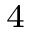Convert formula to latex. <formula><loc_0><loc_0><loc_500><loc_500>_ { 4 }</formula> 